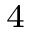Convert formula to latex. <formula><loc_0><loc_0><loc_500><loc_500>_ { 4 }</formula> 